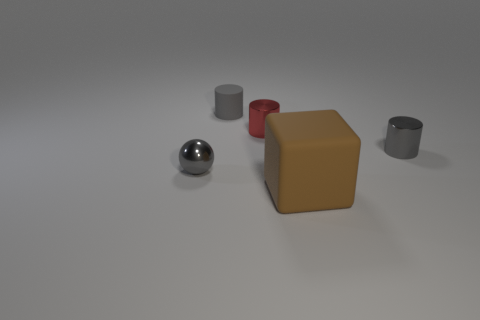Add 4 rubber cylinders. How many objects exist? 9 Subtract all balls. How many objects are left? 4 Subtract all cylinders. Subtract all big brown matte things. How many objects are left? 1 Add 5 small gray spheres. How many small gray spheres are left? 6 Add 5 shiny balls. How many shiny balls exist? 6 Subtract 0 cyan cylinders. How many objects are left? 5 